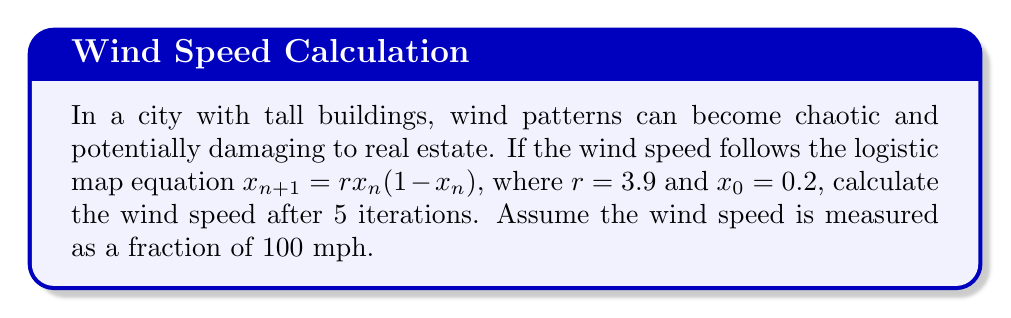Show me your answer to this math problem. Let's iterate the logistic map equation 5 times:

1. Initial value: $x_0 = 0.2$

2. First iteration:
   $x_1 = 3.9 \cdot 0.2 \cdot (1-0.2) = 0.624$

3. Second iteration:
   $x_2 = 3.9 \cdot 0.624 \cdot (1-0.624) = 0.91624704$

4. Third iteration:
   $x_3 = 3.9 \cdot 0.91624704 \cdot (1-0.91624704) = 0.30115607$

5. Fourth iteration:
   $x_4 = 3.9 \cdot 0.30115607 \cdot (1-0.30115607) = 0.82132109$

6. Fifth iteration:
   $x_5 = 3.9 \cdot 0.82132109 \cdot (1-0.82132109) = 0.57134764$

The final value after 5 iterations is 0.57134764, which represents the wind speed as a fraction of 100 mph.

To convert this to mph, we multiply by 100:
$0.57134764 \cdot 100 \approx 57.13$ mph
Answer: 57.13 mph 